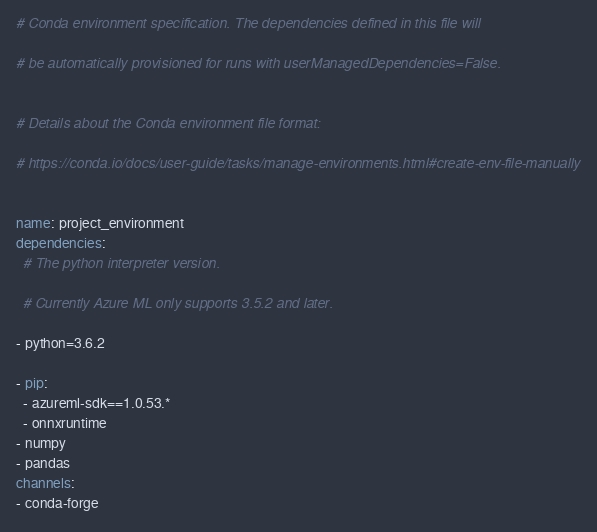<code> <loc_0><loc_0><loc_500><loc_500><_YAML_># Conda environment specification. The dependencies defined in this file will
# be automatically provisioned for runs with userManagedDependencies=False.

# Details about the Conda environment file format:
# https://conda.io/docs/user-guide/tasks/manage-environments.html#create-env-file-manually

name: project_environment
dependencies:
  # The python interpreter version.
  # Currently Azure ML only supports 3.5.2 and later.
- python=3.6.2

- pip:
  - azureml-sdk==1.0.53.*
  - onnxruntime
- numpy
- pandas
channels:
- conda-forge
</code> 